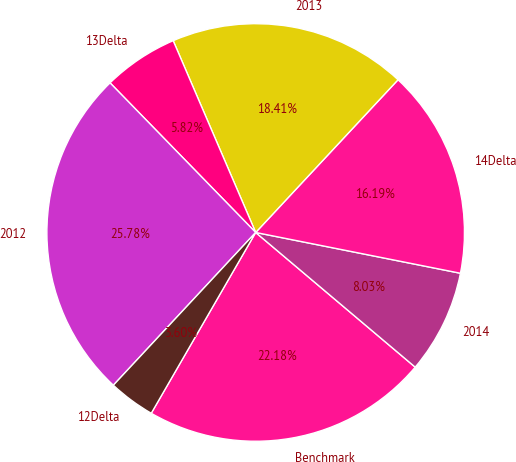<chart> <loc_0><loc_0><loc_500><loc_500><pie_chart><fcel>Benchmark<fcel>2014<fcel>14Delta<fcel>2013<fcel>13Delta<fcel>2012<fcel>12Delta<nl><fcel>22.18%<fcel>8.03%<fcel>16.19%<fcel>18.41%<fcel>5.82%<fcel>25.78%<fcel>3.6%<nl></chart> 